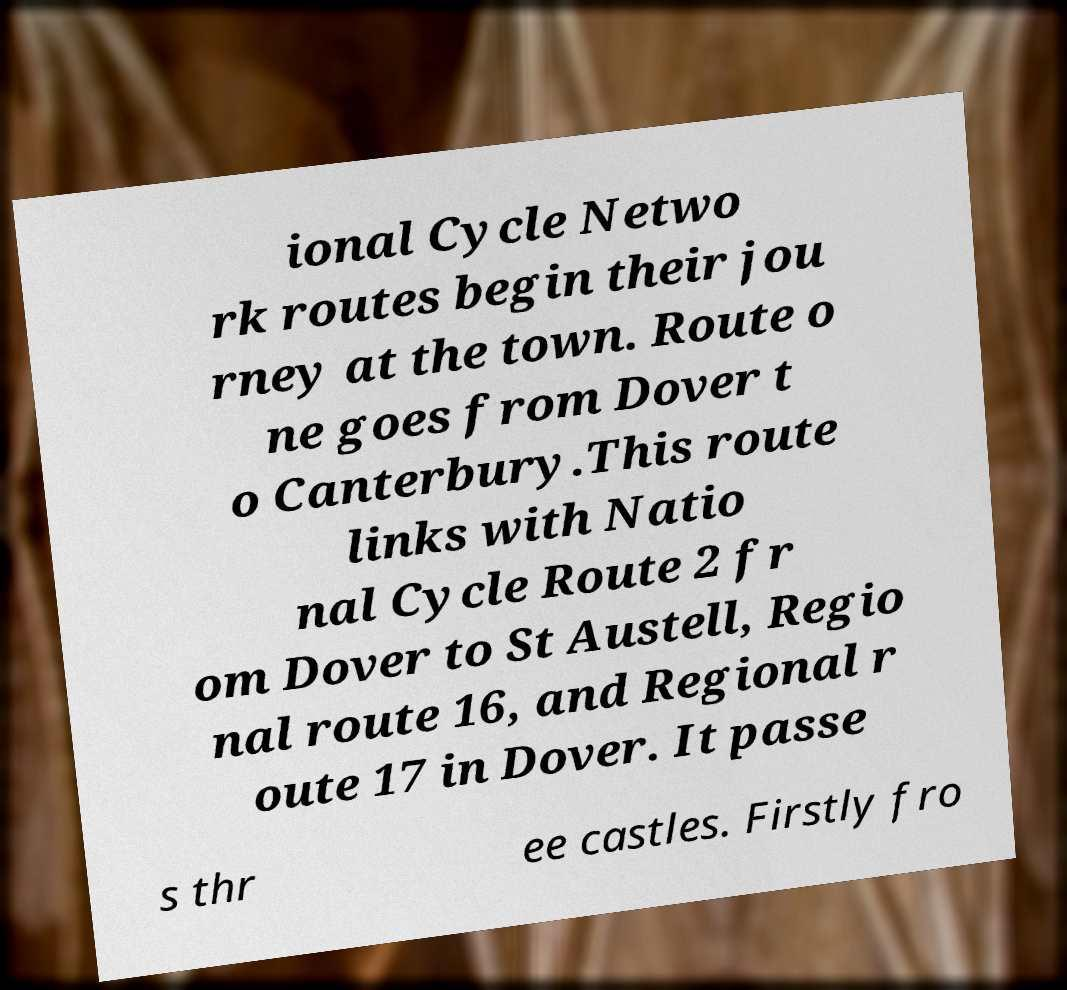Can you read and provide the text displayed in the image?This photo seems to have some interesting text. Can you extract and type it out for me? ional Cycle Netwo rk routes begin their jou rney at the town. Route o ne goes from Dover t o Canterbury.This route links with Natio nal Cycle Route 2 fr om Dover to St Austell, Regio nal route 16, and Regional r oute 17 in Dover. It passe s thr ee castles. Firstly fro 